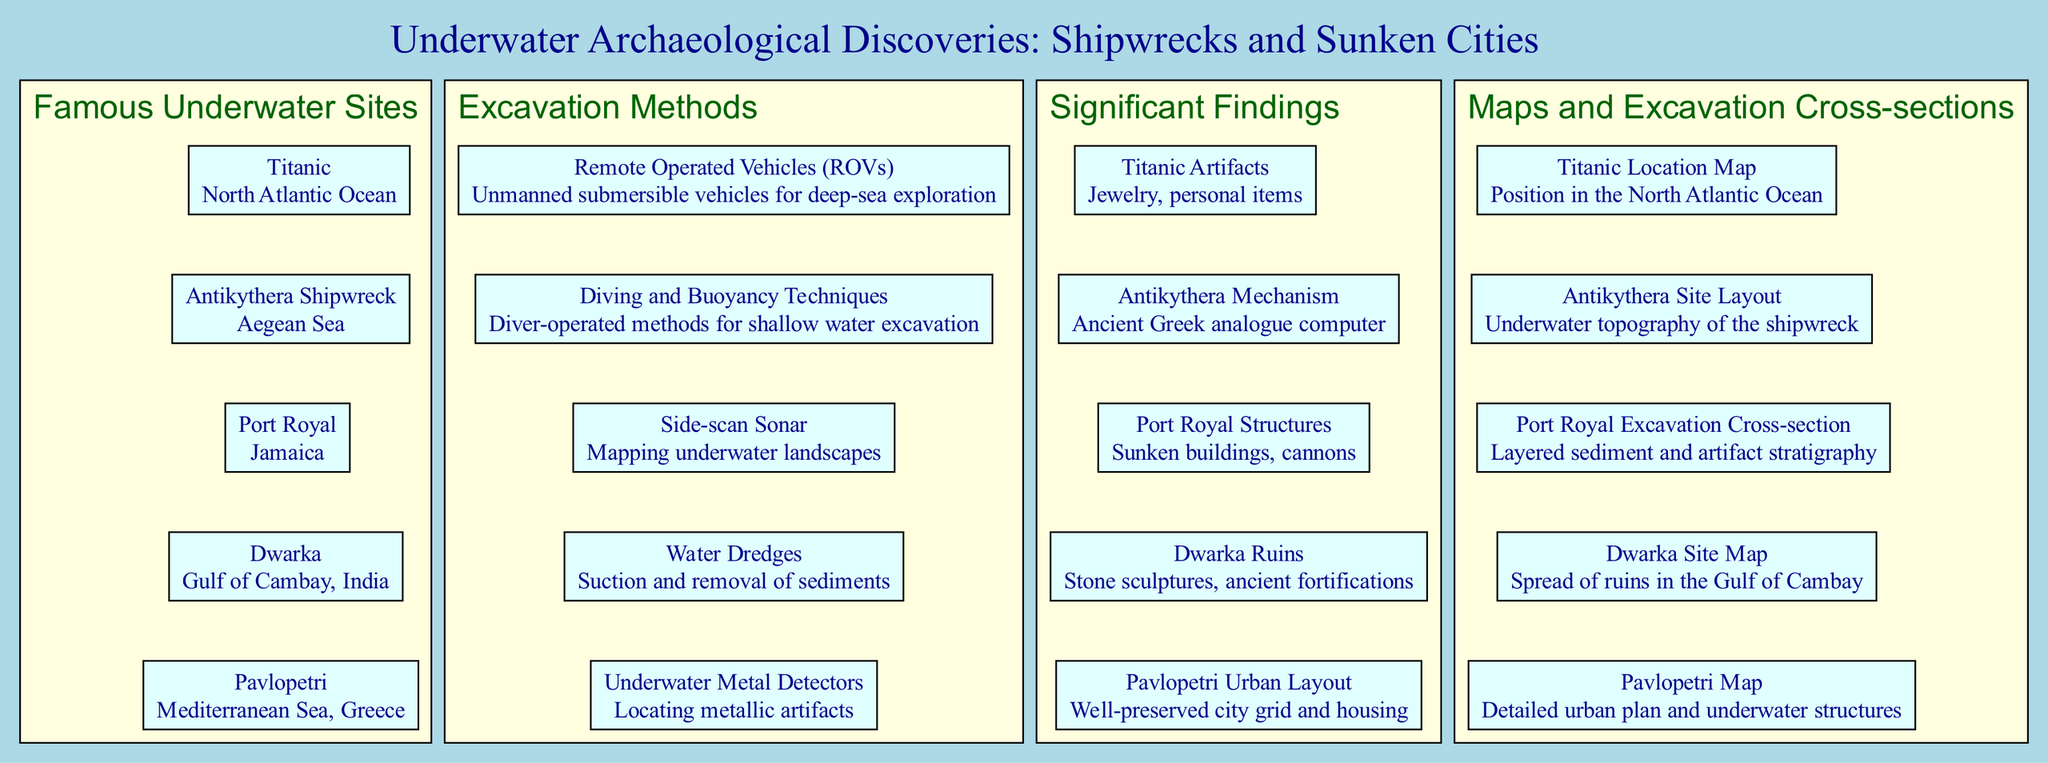What is the location of the Titanic? The Titanic is listed under the "Famous Underwater Sites" section, specifically mentioning "North Atlantic Ocean" as its location.
Answer: North Atlantic Ocean How many famous underwater sites are mentioned? The diagram lists five underwater sites under the "Famous Underwater Sites" section, which can be counted one by one: Titanic, Antikythera Shipwreck, Port Royal, Dwarka, and Pavlopetri.
Answer: 5 What excavation method uses unmanned vehicles? Among the methods highlighted, "Remote Operated Vehicles (ROVs)" clearly specifies that these are unmanned submersible vehicles utilized for deep-sea exploration.
Answer: Remote Operated Vehicles (ROVs) Which site has well-preserved urban planning? In the "Significant Findings" section, the entry for Pavlopetri indicates that it showcases a "Well-preserved city grid and housing," reflecting its historical urban layout.
Answer: Pavlopetri What is the main finding from the Antikythera shipwreck? The notable artifact associated with the Antikythera shipwreck is the "Antikythera Mechanism," described as an ancient Greek analogue computer in the "Significant Findings" section.
Answer: Antikythera Mechanism What is depicted in the Port Royal excavation cross-section? The "Port Royal Excavation Cross-section" reveals information about the layered sediment and artifact stratigraphy, emphasizing its archaeological complexity.
Answer: Layered sediment and artifact stratigraphy What mapping technique is used for underwater landscapes? The diagram describes "Side-scan Sonar" as the method used for mapping underwater landscapes, making it clear how underwater geography is studied.
Answer: Side-scan Sonar Which method is used for locating metallic artifacts? Under the excavation methods, "Underwater Metal Detectors" are explicitly described as the technique for locating metallic artifacts in underwater archaeological sites.
Answer: Underwater Metal Detectors 